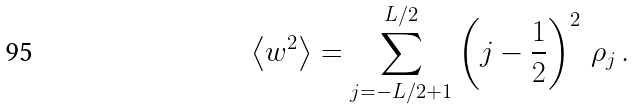Convert formula to latex. <formula><loc_0><loc_0><loc_500><loc_500>\left \langle w ^ { 2 } \right \rangle = \sum ^ { L / 2 } _ { j = - L / 2 + 1 } \left ( j - \frac { 1 } { 2 } \right ) ^ { 2 } \, \rho _ { j } \, .</formula> 